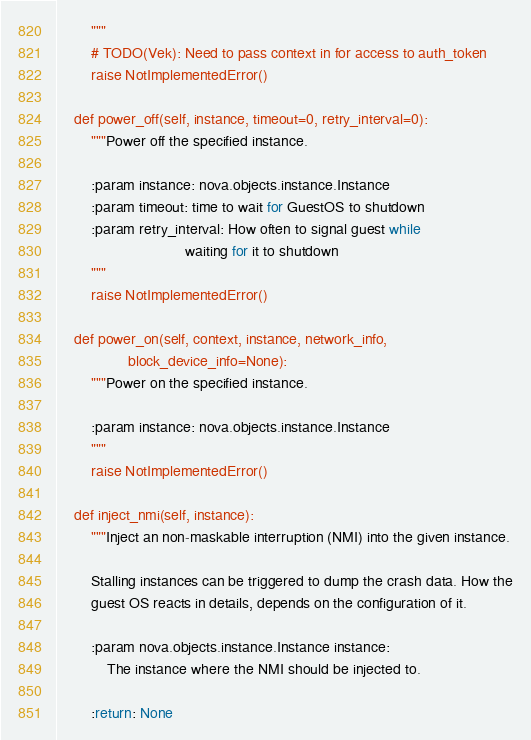<code> <loc_0><loc_0><loc_500><loc_500><_Python_>        """
        # TODO(Vek): Need to pass context in for access to auth_token
        raise NotImplementedError()

    def power_off(self, instance, timeout=0, retry_interval=0):
        """Power off the specified instance.

        :param instance: nova.objects.instance.Instance
        :param timeout: time to wait for GuestOS to shutdown
        :param retry_interval: How often to signal guest while
                               waiting for it to shutdown
        """
        raise NotImplementedError()

    def power_on(self, context, instance, network_info,
                 block_device_info=None):
        """Power on the specified instance.

        :param instance: nova.objects.instance.Instance
        """
        raise NotImplementedError()

    def inject_nmi(self, instance):
        """Inject an non-maskable interruption (NMI) into the given instance.

        Stalling instances can be triggered to dump the crash data. How the
        guest OS reacts in details, depends on the configuration of it.

        :param nova.objects.instance.Instance instance:
            The instance where the NMI should be injected to.

        :return: None</code> 